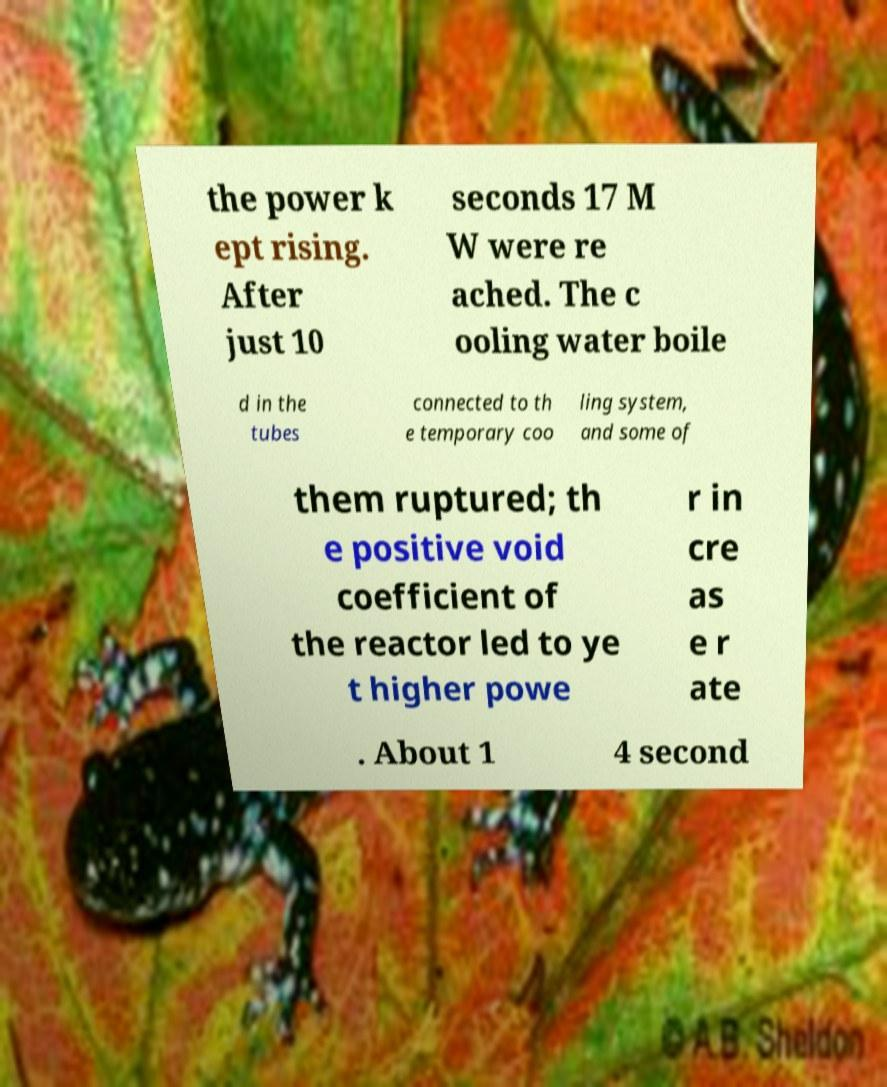Please read and relay the text visible in this image. What does it say? the power k ept rising. After just 10 seconds 17 M W were re ached. The c ooling water boile d in the tubes connected to th e temporary coo ling system, and some of them ruptured; th e positive void coefficient of the reactor led to ye t higher powe r in cre as e r ate . About 1 4 second 